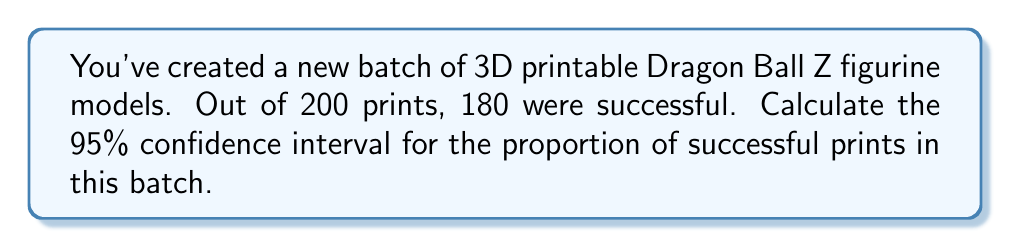Provide a solution to this math problem. Let's approach this step-by-step:

1) First, we need to identify our values:
   $n$ (sample size) = 200
   $x$ (number of successes) = 180
   Confidence level = 95% (z-score = 1.96)

2) Calculate the sample proportion ($\hat{p}$):
   $$\hat{p} = \frac{x}{n} = \frac{180}{200} = 0.9$$

3) Calculate the standard error (SE):
   $$SE = \sqrt{\frac{\hat{p}(1-\hat{p})}{n}} = \sqrt{\frac{0.9(1-0.9)}{200}} = \sqrt{\frac{0.09}{200}} = 0.0212$$

4) The formula for the confidence interval is:
   $$\hat{p} \pm (z \times SE)$$

   Where $z$ is the z-score for our confidence level (1.96 for 95% confidence)

5) Plug in our values:
   $$0.9 \pm (1.96 \times 0.0212)$$
   $$0.9 \pm 0.0416$$

6) Calculate the lower and upper bounds:
   Lower bound: $0.9 - 0.0416 = 0.8584$
   Upper bound: $0.9 + 0.0416 = 0.9416$

Therefore, we can say with 95% confidence that the true proportion of successful prints in this batch of Dragon Ball Z models is between 0.8584 and 0.9416, or between 85.84% and 94.16%.
Answer: (0.8584, 0.9416) 